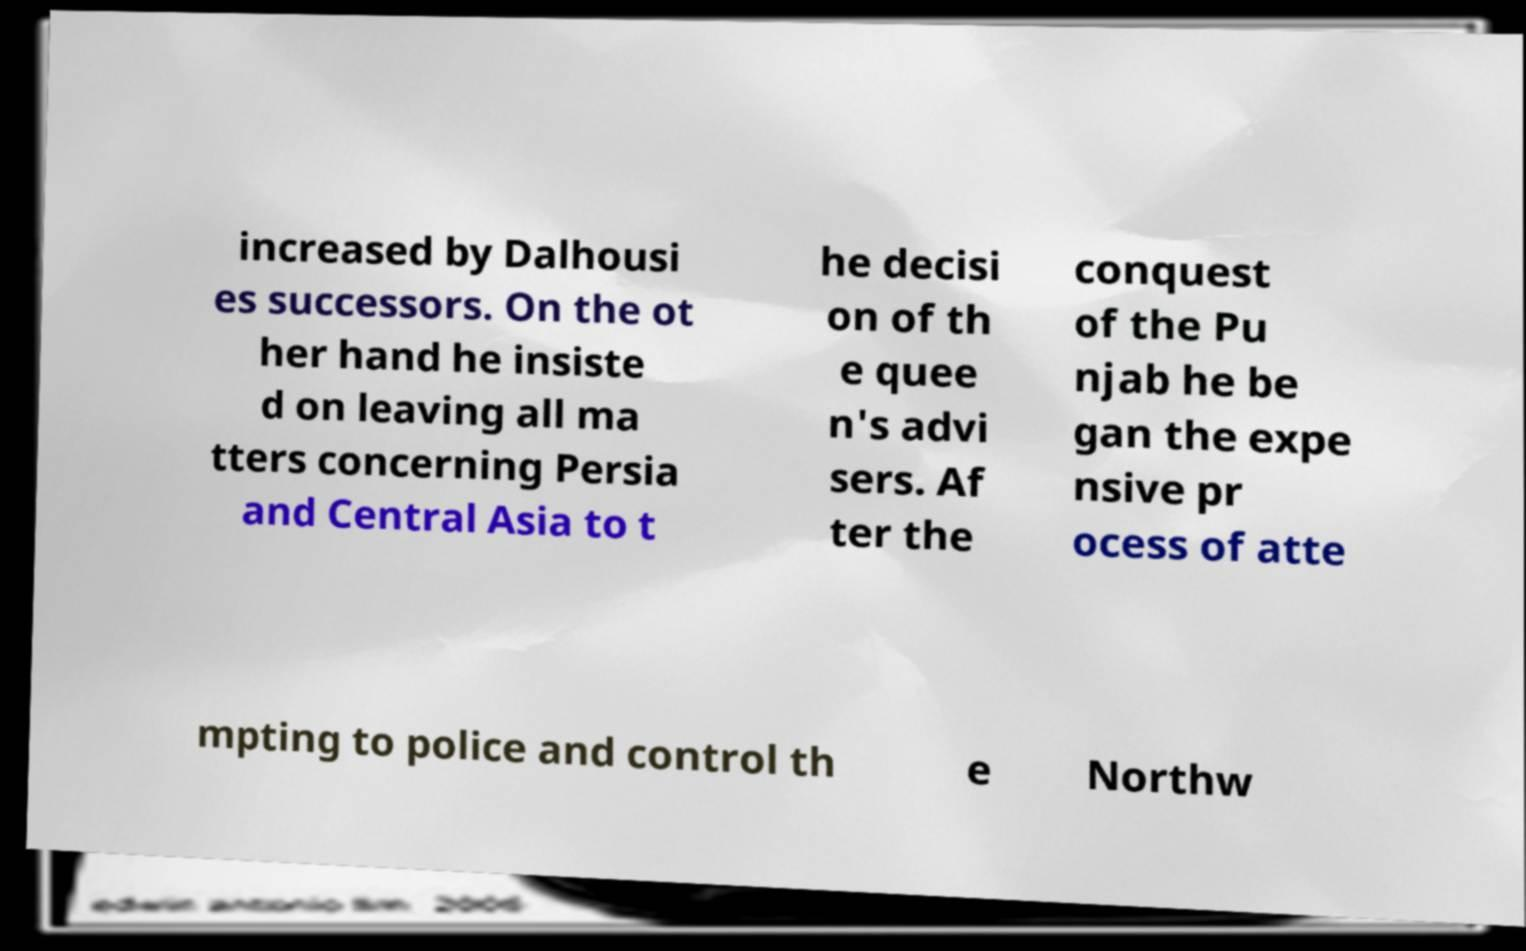I need the written content from this picture converted into text. Can you do that? increased by Dalhousi es successors. On the ot her hand he insiste d on leaving all ma tters concerning Persia and Central Asia to t he decisi on of th e quee n's advi sers. Af ter the conquest of the Pu njab he be gan the expe nsive pr ocess of atte mpting to police and control th e Northw 